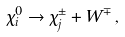<formula> <loc_0><loc_0><loc_500><loc_500>\chi ^ { 0 } _ { i } \rightarrow \chi _ { j } ^ { \pm } + W ^ { \mp } \, ,</formula> 